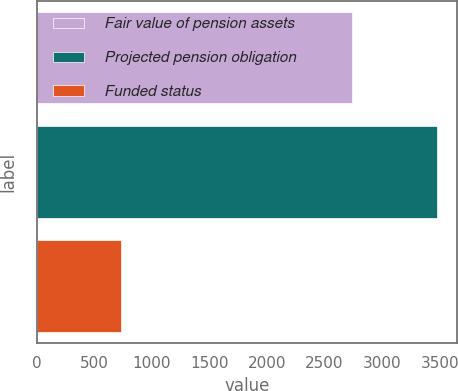<chart> <loc_0><loc_0><loc_500><loc_500><bar_chart><fcel>Fair value of pension assets<fcel>Projected pension obligation<fcel>Funded status<nl><fcel>2742<fcel>3477<fcel>735<nl></chart> 